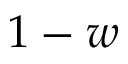Convert formula to latex. <formula><loc_0><loc_0><loc_500><loc_500>1 - w</formula> 